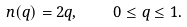Convert formula to latex. <formula><loc_0><loc_0><loc_500><loc_500>n ( q ) = 2 q , \quad \ 0 \leq q \leq 1 .</formula> 